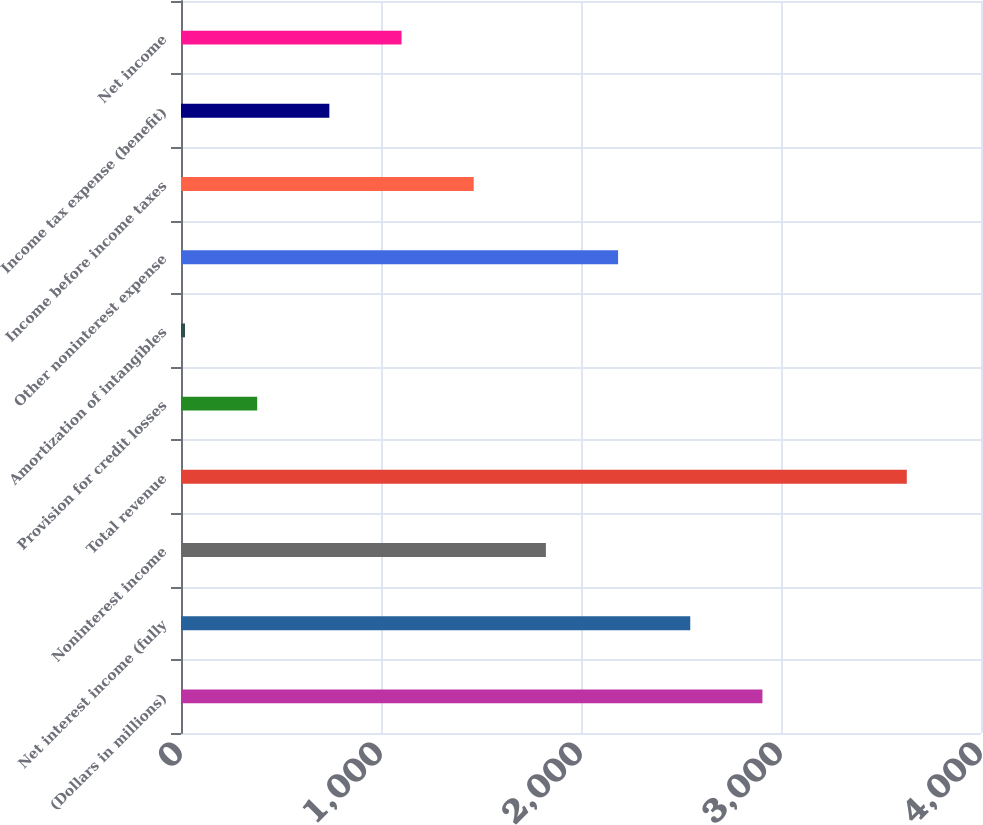<chart> <loc_0><loc_0><loc_500><loc_500><bar_chart><fcel>(Dollars in millions)<fcel>Net interest income (fully<fcel>Noninterest income<fcel>Total revenue<fcel>Provision for credit losses<fcel>Amortization of intangibles<fcel>Other noninterest expense<fcel>Income before income taxes<fcel>Income tax expense (benefit)<fcel>Net income<nl><fcel>2907.2<fcel>2546.3<fcel>1824.5<fcel>3629<fcel>380.9<fcel>20<fcel>2185.4<fcel>1463.6<fcel>741.8<fcel>1102.7<nl></chart> 